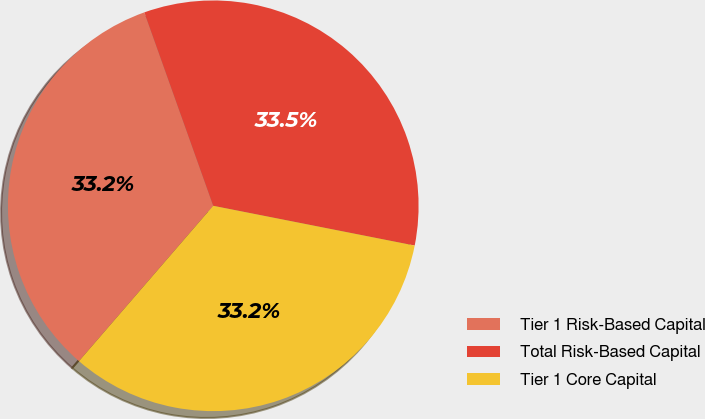Convert chart. <chart><loc_0><loc_0><loc_500><loc_500><pie_chart><fcel>Tier 1 Risk-Based Capital<fcel>Total Risk-Based Capital<fcel>Tier 1 Core Capital<nl><fcel>33.21%<fcel>33.55%<fcel>33.24%<nl></chart> 